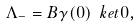Convert formula to latex. <formula><loc_0><loc_0><loc_500><loc_500>\Lambda _ { - } = B \gamma ( 0 ) \ k e t { 0 } ,</formula> 